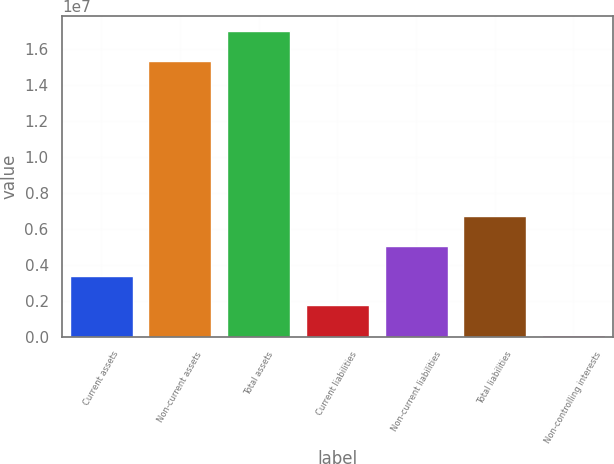Convert chart. <chart><loc_0><loc_0><loc_500><loc_500><bar_chart><fcel>Current assets<fcel>Non-current assets<fcel>Total assets<fcel>Current liabilities<fcel>Non-current liabilities<fcel>Total liabilities<fcel>Non-controlling interests<nl><fcel>3.40161e+06<fcel>1.53695e+07<fcel>1.70285e+07<fcel>1.7426e+06<fcel>5.06063e+06<fcel>6.71965e+06<fcel>83579<nl></chart> 